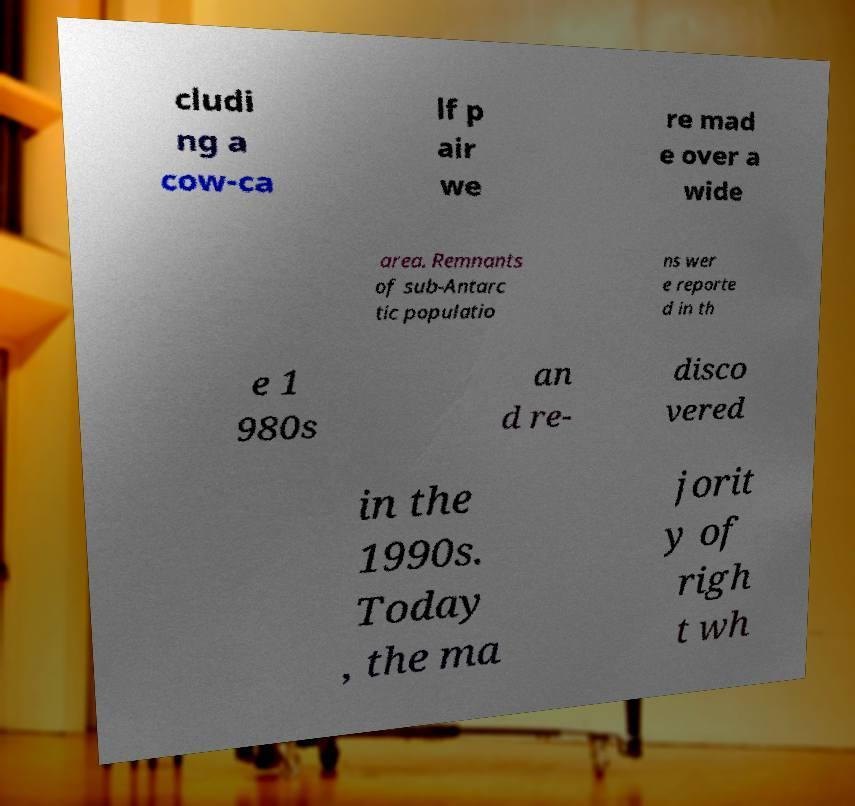For documentation purposes, I need the text within this image transcribed. Could you provide that? cludi ng a cow-ca lf p air we re mad e over a wide area. Remnants of sub-Antarc tic populatio ns wer e reporte d in th e 1 980s an d re- disco vered in the 1990s. Today , the ma jorit y of righ t wh 